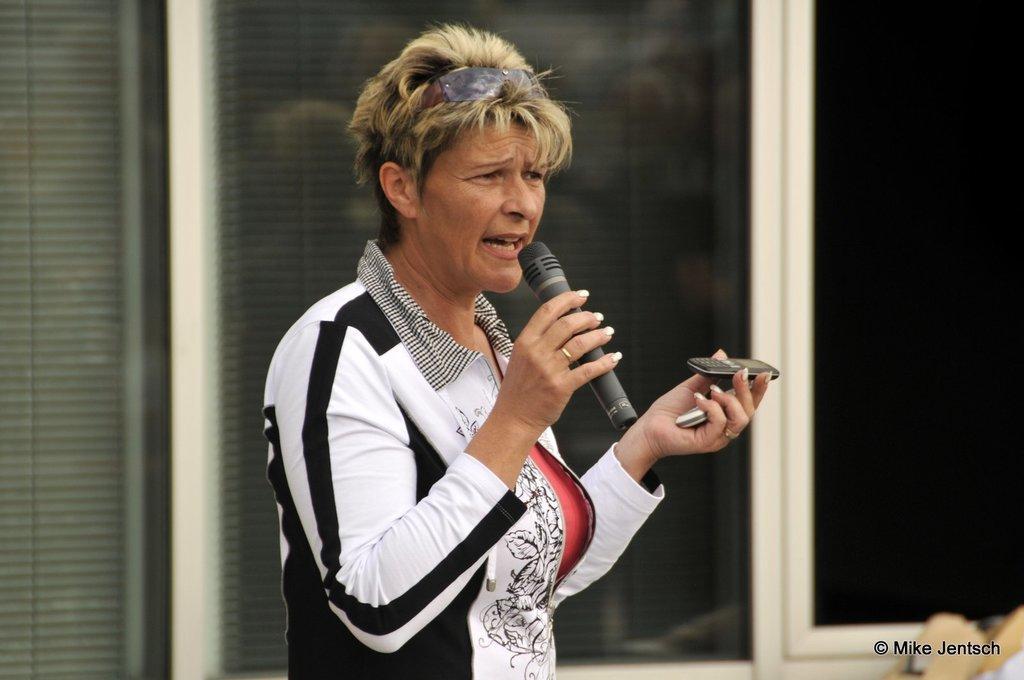Please provide a concise description of this image. In this picture there is a woman wearing a black and white jacket. She is holding a mike in one hand and mobiles in another hand. In the background there is a house. 